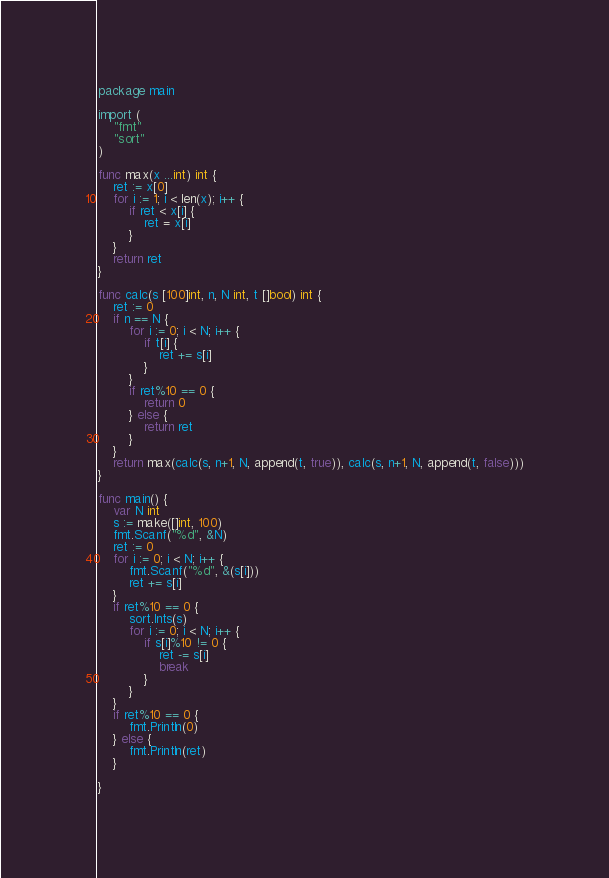<code> <loc_0><loc_0><loc_500><loc_500><_Go_>package main

import (
	"fmt"
	"sort"
)

func max(x ...int) int {
	ret := x[0]
	for i := 1; i < len(x); i++ {
		if ret < x[i] {
			ret = x[i]
		}
	}
	return ret
}

func calc(s [100]int, n, N int, t []bool) int {
	ret := 0
	if n == N {
		for i := 0; i < N; i++ {
			if t[i] {
				ret += s[i]
			}
		}
		if ret%10 == 0 {
			return 0
		} else {
			return ret
		}
	}
	return max(calc(s, n+1, N, append(t, true)), calc(s, n+1, N, append(t, false)))
}

func main() {
	var N int
	s := make([]int, 100)
	fmt.Scanf("%d", &N)
	ret := 0
	for i := 0; i < N; i++ {
		fmt.Scanf("%d", &(s[i]))
		ret += s[i]
	}
	if ret%10 == 0 {
		sort.Ints(s)
		for i := 0; i < N; i++ {
			if s[i]%10 != 0 {
				ret -= s[i]
				break
			}
		}
	}
	if ret%10 == 0 {
		fmt.Println(0)
	} else {
		fmt.Println(ret)
	}

}
</code> 